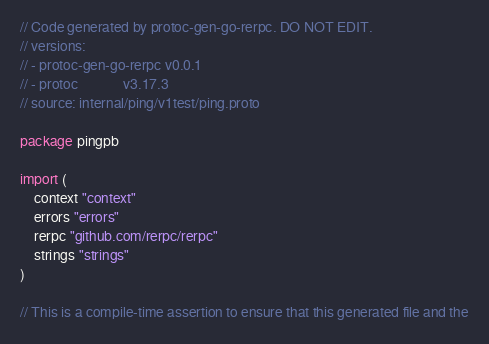<code> <loc_0><loc_0><loc_500><loc_500><_Go_>// Code generated by protoc-gen-go-rerpc. DO NOT EDIT.
// versions:
// - protoc-gen-go-rerpc v0.0.1
// - protoc             v3.17.3
// source: internal/ping/v1test/ping.proto

package pingpb

import (
	context "context"
	errors "errors"
	rerpc "github.com/rerpc/rerpc"
	strings "strings"
)

// This is a compile-time assertion to ensure that this generated file and the</code> 